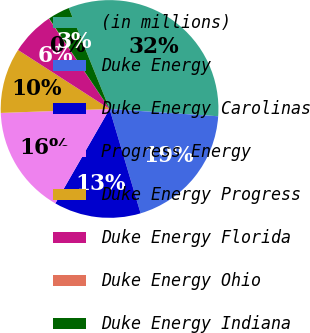Convert chart. <chart><loc_0><loc_0><loc_500><loc_500><pie_chart><fcel>(in millions)<fcel>Duke Energy<fcel>Duke Energy Carolinas<fcel>Progress Energy<fcel>Duke Energy Progress<fcel>Duke Energy Florida<fcel>Duke Energy Ohio<fcel>Duke Energy Indiana<nl><fcel>32.18%<fcel>19.33%<fcel>12.9%<fcel>16.12%<fcel>9.69%<fcel>6.47%<fcel>0.05%<fcel>3.26%<nl></chart> 